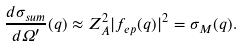<formula> <loc_0><loc_0><loc_500><loc_500>\frac { d \sigma _ { s u m } } { d \Omega ^ { \prime } } ( q ) \approx Z _ { A } ^ { 2 } | f _ { e p } ( q ) | ^ { 2 } = \sigma _ { M } ( q ) .</formula> 